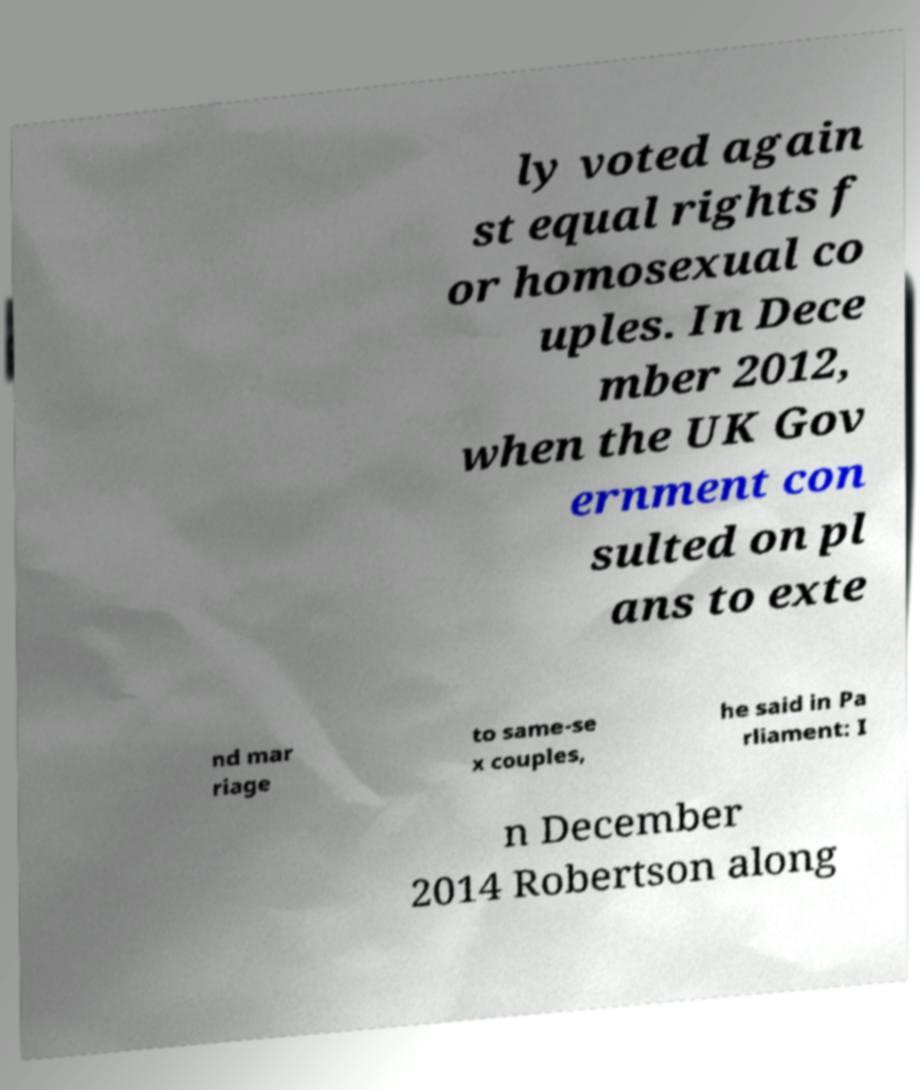Could you extract and type out the text from this image? ly voted again st equal rights f or homosexual co uples. In Dece mber 2012, when the UK Gov ernment con sulted on pl ans to exte nd mar riage to same-se x couples, he said in Pa rliament: I n December 2014 Robertson along 